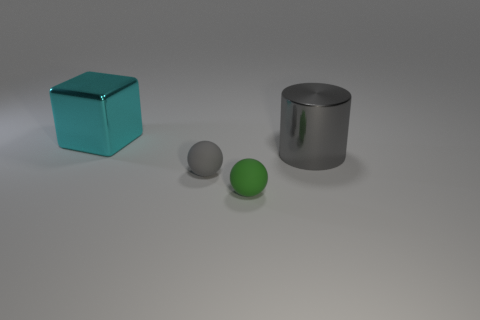There is a small thing that is the same color as the large metallic cylinder; what is it made of?
Make the answer very short. Rubber. Is there a sphere of the same size as the cyan shiny block?
Provide a succinct answer. No. There is a gray object that is the same size as the cube; what shape is it?
Your answer should be compact. Cylinder. Are there any cyan shiny things that have the same shape as the gray metallic object?
Make the answer very short. No. Is the big cyan cube made of the same material as the small ball behind the green ball?
Provide a short and direct response. No. Is there a shiny cylinder that has the same color as the metal block?
Ensure brevity in your answer.  No. What number of other objects are there of the same material as the tiny gray thing?
Provide a short and direct response. 1. There is a cylinder; is it the same color as the tiny sphere behind the small green thing?
Give a very brief answer. Yes. Are there more large cyan cubes on the right side of the green matte ball than tiny gray matte things?
Provide a short and direct response. No. How many small green balls are behind the gray ball that is in front of the big object that is left of the big gray metal cylinder?
Make the answer very short. 0. 